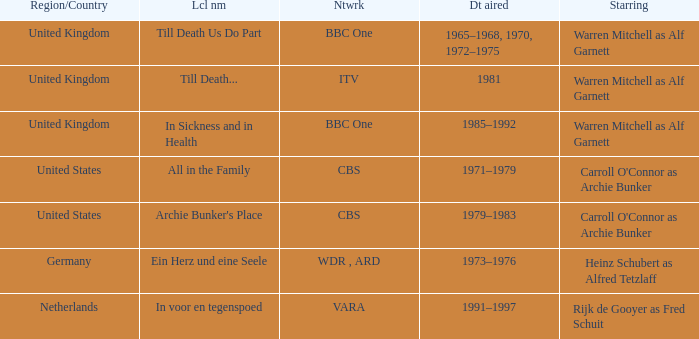Who was the star for the Vara network? Rijk de Gooyer as Fred Schuit. 